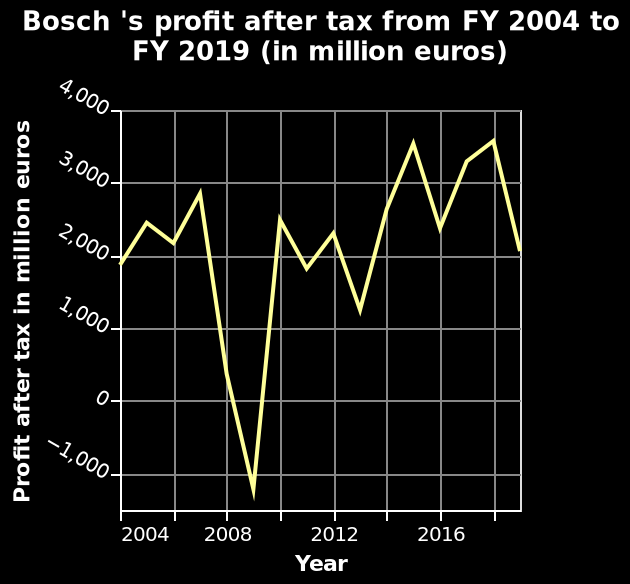<image>
What was the overall trend in tax profits between 2007 and 2010? Tax profits initially fell sharply into negative numbers but then rebounded significantly between 2009 and 2010. What happened to tax profits between 2009 and 2010? Tax profits experienced a sharp increase during this period. In what unit is the profit after tax represented in the line chart? The profit after tax is represented in million euros in the line chart. 